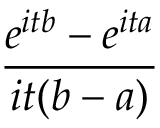<formula> <loc_0><loc_0><loc_500><loc_500>\, { \frac { e ^ { i t b } - e ^ { i t a } } { i t ( b - a ) } }</formula> 